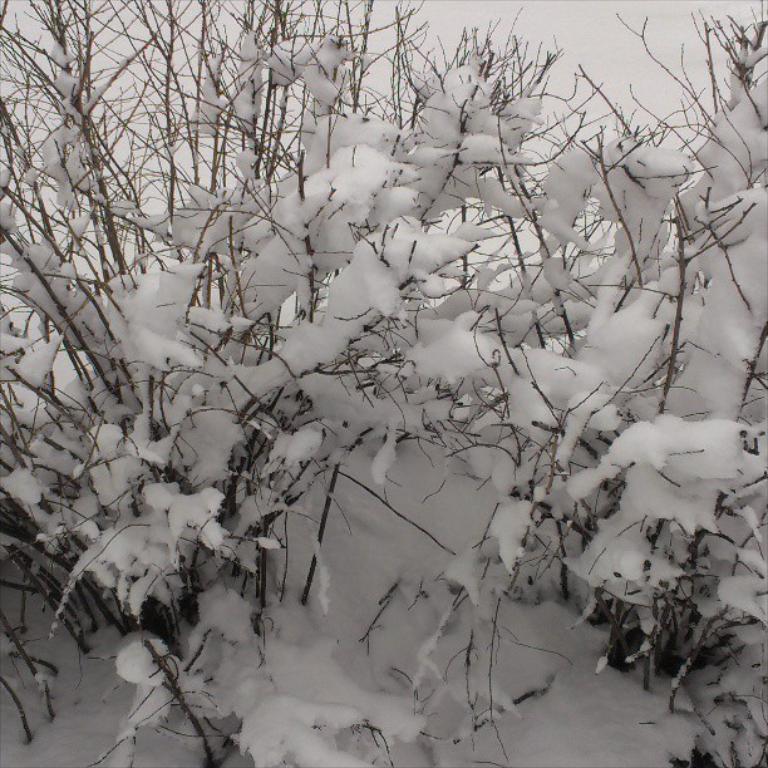Can you describe this image briefly? In this image I can see few plants covered with the snow. 